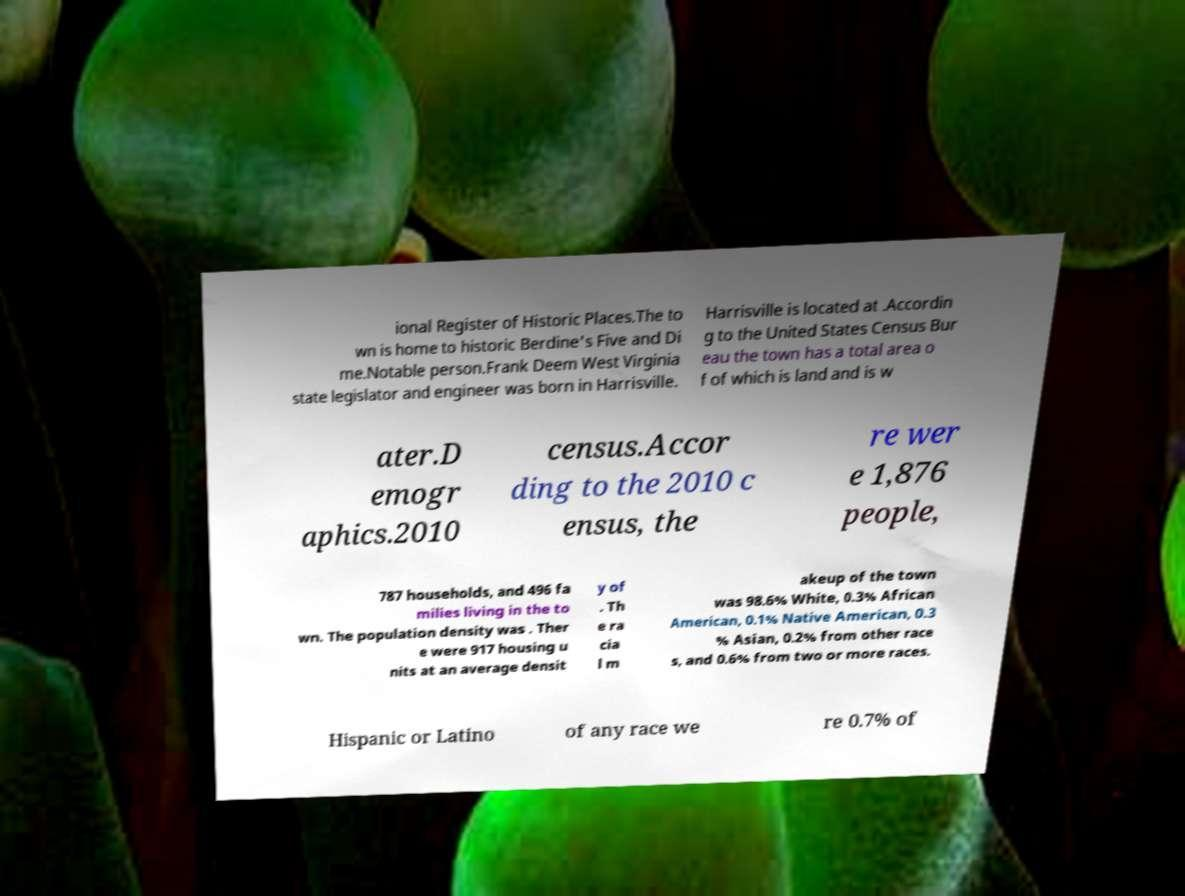Can you accurately transcribe the text from the provided image for me? ional Register of Historic Places.The to wn is home to historic Berdine's Five and Di me.Notable person.Frank Deem West Virginia state legislator and engineer was born in Harrisville. Harrisville is located at .Accordin g to the United States Census Bur eau the town has a total area o f of which is land and is w ater.D emogr aphics.2010 census.Accor ding to the 2010 c ensus, the re wer e 1,876 people, 787 households, and 496 fa milies living in the to wn. The population density was . Ther e were 917 housing u nits at an average densit y of . Th e ra cia l m akeup of the town was 98.6% White, 0.3% African American, 0.1% Native American, 0.3 % Asian, 0.2% from other race s, and 0.6% from two or more races. Hispanic or Latino of any race we re 0.7% of 